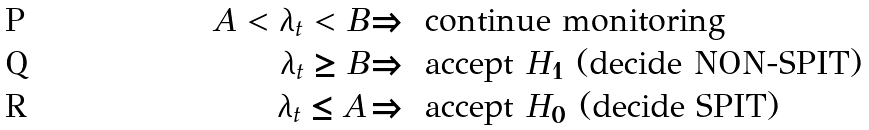Convert formula to latex. <formula><loc_0><loc_0><loc_500><loc_500>A < \lambda _ { t } < B & \Longrightarrow \text { continue monitoring} \\ \lambda _ { t } \geq B & \Longrightarrow \text { accept } H _ { 1 } \text { (decide NON-SPIT)} \\ \lambda _ { t } \leq A & \Longrightarrow \text { accept } H _ { 0 } \text { (decide SPIT)}</formula> 